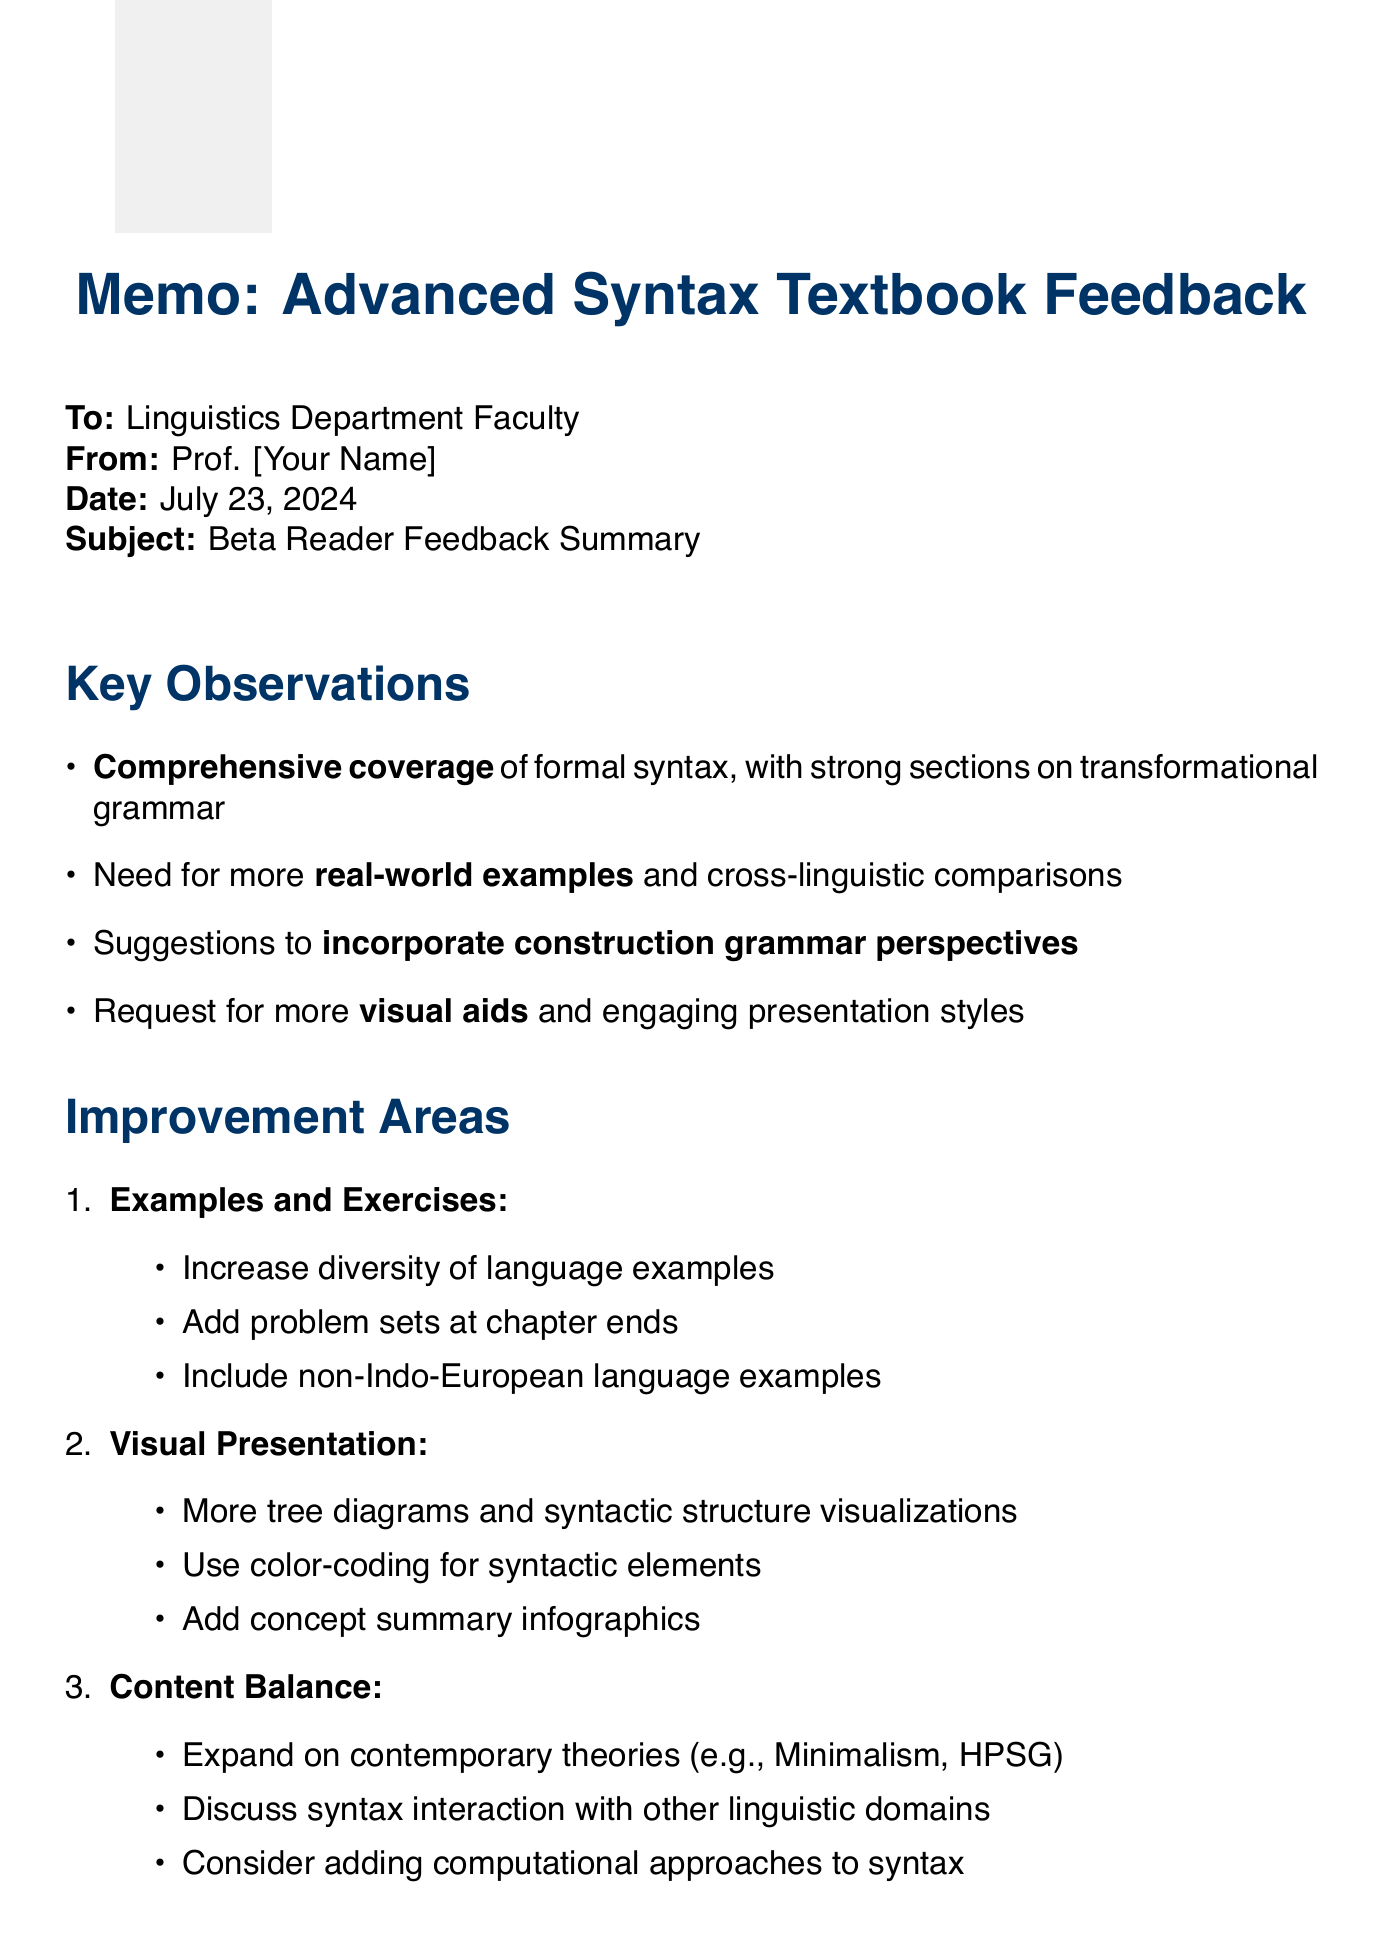What is the overall impression from Dr. Noam Chomsky? Dr. Chomsky's overall impression is summarized as being comprehensive and well-structured, but with a need for more real-world examples.
Answer: Comprehensive and well-structured, but could benefit from more real-world examples What specific suggestion did Prof. Adele Goldberg make regarding language examples? Prof. Goldberg suggested that the chapter on argument structure could benefit from more diverse language examples for better clarity.
Answer: More diverse language examples How many areas for improvement are highlighted in the memo? The memo outlines three distinct areas for improvement regarding the textbook content and presentation.
Answer: Three What is one of the clarification needs for the topic of Syntactic Movement? One clarification point requested is for clearer explanations of A-movement vs. A'-movement to enhance understanding.
Answer: Clearer explanations of A-movement vs. A'-movement Which university is Dr. Steven Pinker affiliated with? Dr. Pinker is affiliated with Harvard University, indicating his prestigious background in psychology and linguistics.
Answer: Harvard University What visual aids does the memo suggest incorporating to improve presentation? The memo suggests incorporating more diagrams and visual aids to explain complex syntactic structures for better understanding.
Answer: More diagrams and visual aids What specific content area do the feedback suggestions for Content Balance focus on? The suggestions for Content Balance include expanding coverage of contemporary syntactic theories like Minimalism and HPSG.
Answer: Contemporary syntactic theories, such as Minimalism and HPSG How does the memo recommend incorporating exercises? The recommendation in the memo is to add exercises at the end of each chapter for self-assessment purposes.
Answer: Add exercises at the end of each chapter What is one area identified for adding more examples? The need to include more examples from non-Indo-European languages is highlighted as an important area for inclusion.
Answer: Non-Indo-European languages 